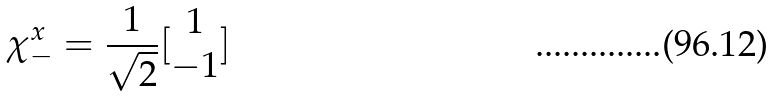<formula> <loc_0><loc_0><loc_500><loc_500>\chi _ { - } ^ { x } = \frac { 1 } { \sqrt { 2 } } [ \begin{matrix} 1 \\ - 1 \\ \end{matrix} ]</formula> 